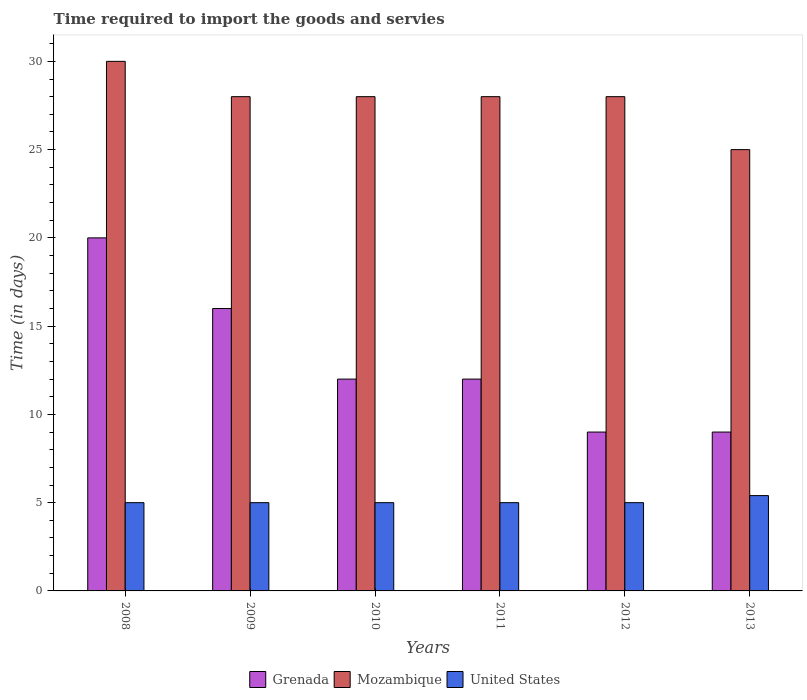How many different coloured bars are there?
Your answer should be very brief. 3. Are the number of bars per tick equal to the number of legend labels?
Give a very brief answer. Yes. How many bars are there on the 4th tick from the left?
Offer a terse response. 3. In how many cases, is the number of bars for a given year not equal to the number of legend labels?
Your answer should be very brief. 0. What is the number of days required to import the goods and services in Grenada in 2013?
Give a very brief answer. 9. Across all years, what is the maximum number of days required to import the goods and services in Mozambique?
Make the answer very short. 30. In which year was the number of days required to import the goods and services in United States maximum?
Your response must be concise. 2013. In which year was the number of days required to import the goods and services in United States minimum?
Ensure brevity in your answer.  2008. What is the total number of days required to import the goods and services in Grenada in the graph?
Provide a succinct answer. 78. What is the difference between the number of days required to import the goods and services in Mozambique in 2008 and the number of days required to import the goods and services in Grenada in 2013?
Offer a very short reply. 21. What is the average number of days required to import the goods and services in United States per year?
Give a very brief answer. 5.07. In the year 2013, what is the difference between the number of days required to import the goods and services in United States and number of days required to import the goods and services in Mozambique?
Give a very brief answer. -19.6. What is the ratio of the number of days required to import the goods and services in Mozambique in 2008 to that in 2011?
Offer a very short reply. 1.07. Is the number of days required to import the goods and services in Mozambique in 2009 less than that in 2012?
Keep it short and to the point. No. Is the difference between the number of days required to import the goods and services in United States in 2010 and 2013 greater than the difference between the number of days required to import the goods and services in Mozambique in 2010 and 2013?
Ensure brevity in your answer.  No. What is the difference between the highest and the lowest number of days required to import the goods and services in United States?
Your answer should be very brief. 0.4. What does the 2nd bar from the left in 2011 represents?
Your answer should be very brief. Mozambique. Is it the case that in every year, the sum of the number of days required to import the goods and services in United States and number of days required to import the goods and services in Grenada is greater than the number of days required to import the goods and services in Mozambique?
Give a very brief answer. No. Are all the bars in the graph horizontal?
Provide a succinct answer. No. How many years are there in the graph?
Ensure brevity in your answer.  6. How many legend labels are there?
Provide a short and direct response. 3. What is the title of the graph?
Make the answer very short. Time required to import the goods and servies. What is the label or title of the Y-axis?
Your answer should be very brief. Time (in days). What is the Time (in days) of Grenada in 2008?
Keep it short and to the point. 20. What is the Time (in days) in United States in 2008?
Make the answer very short. 5. What is the Time (in days) of Grenada in 2009?
Offer a terse response. 16. What is the Time (in days) in Grenada in 2010?
Offer a very short reply. 12. What is the Time (in days) of Grenada in 2011?
Give a very brief answer. 12. What is the Time (in days) of United States in 2011?
Your answer should be compact. 5. What is the Time (in days) in Mozambique in 2012?
Keep it short and to the point. 28. What is the Time (in days) in United States in 2012?
Give a very brief answer. 5. What is the Time (in days) in Mozambique in 2013?
Offer a terse response. 25. Across all years, what is the maximum Time (in days) in Grenada?
Your answer should be compact. 20. Across all years, what is the maximum Time (in days) of United States?
Keep it short and to the point. 5.4. What is the total Time (in days) of Grenada in the graph?
Offer a terse response. 78. What is the total Time (in days) of Mozambique in the graph?
Your response must be concise. 167. What is the total Time (in days) of United States in the graph?
Keep it short and to the point. 30.4. What is the difference between the Time (in days) in Grenada in 2008 and that in 2009?
Offer a very short reply. 4. What is the difference between the Time (in days) of Mozambique in 2008 and that in 2010?
Provide a short and direct response. 2. What is the difference between the Time (in days) of United States in 2008 and that in 2010?
Offer a very short reply. 0. What is the difference between the Time (in days) in Grenada in 2008 and that in 2012?
Offer a very short reply. 11. What is the difference between the Time (in days) in Grenada in 2008 and that in 2013?
Your response must be concise. 11. What is the difference between the Time (in days) of Mozambique in 2008 and that in 2013?
Your response must be concise. 5. What is the difference between the Time (in days) in Grenada in 2009 and that in 2010?
Offer a very short reply. 4. What is the difference between the Time (in days) of Mozambique in 2009 and that in 2010?
Keep it short and to the point. 0. What is the difference between the Time (in days) of United States in 2009 and that in 2010?
Provide a short and direct response. 0. What is the difference between the Time (in days) in Mozambique in 2009 and that in 2011?
Your answer should be compact. 0. What is the difference between the Time (in days) of United States in 2009 and that in 2011?
Offer a terse response. 0. What is the difference between the Time (in days) in Mozambique in 2009 and that in 2012?
Provide a succinct answer. 0. What is the difference between the Time (in days) of Grenada in 2009 and that in 2013?
Make the answer very short. 7. What is the difference between the Time (in days) in Grenada in 2010 and that in 2011?
Give a very brief answer. 0. What is the difference between the Time (in days) of Grenada in 2010 and that in 2012?
Keep it short and to the point. 3. What is the difference between the Time (in days) in Mozambique in 2010 and that in 2012?
Keep it short and to the point. 0. What is the difference between the Time (in days) in United States in 2010 and that in 2012?
Offer a terse response. 0. What is the difference between the Time (in days) of United States in 2010 and that in 2013?
Give a very brief answer. -0.4. What is the difference between the Time (in days) in Grenada in 2011 and that in 2012?
Offer a very short reply. 3. What is the difference between the Time (in days) in United States in 2011 and that in 2012?
Make the answer very short. 0. What is the difference between the Time (in days) in United States in 2011 and that in 2013?
Your answer should be compact. -0.4. What is the difference between the Time (in days) of Grenada in 2008 and the Time (in days) of Mozambique in 2009?
Provide a succinct answer. -8. What is the difference between the Time (in days) of Mozambique in 2008 and the Time (in days) of United States in 2009?
Offer a terse response. 25. What is the difference between the Time (in days) in Grenada in 2008 and the Time (in days) in United States in 2010?
Your answer should be compact. 15. What is the difference between the Time (in days) in Grenada in 2008 and the Time (in days) in Mozambique in 2011?
Offer a terse response. -8. What is the difference between the Time (in days) in Grenada in 2008 and the Time (in days) in United States in 2011?
Offer a very short reply. 15. What is the difference between the Time (in days) of Mozambique in 2008 and the Time (in days) of United States in 2011?
Ensure brevity in your answer.  25. What is the difference between the Time (in days) of Grenada in 2008 and the Time (in days) of Mozambique in 2012?
Ensure brevity in your answer.  -8. What is the difference between the Time (in days) of Grenada in 2008 and the Time (in days) of United States in 2012?
Your response must be concise. 15. What is the difference between the Time (in days) of Grenada in 2008 and the Time (in days) of Mozambique in 2013?
Keep it short and to the point. -5. What is the difference between the Time (in days) of Mozambique in 2008 and the Time (in days) of United States in 2013?
Provide a succinct answer. 24.6. What is the difference between the Time (in days) of Grenada in 2009 and the Time (in days) of United States in 2010?
Make the answer very short. 11. What is the difference between the Time (in days) of Mozambique in 2009 and the Time (in days) of United States in 2010?
Your response must be concise. 23. What is the difference between the Time (in days) in Grenada in 2009 and the Time (in days) in Mozambique in 2011?
Provide a short and direct response. -12. What is the difference between the Time (in days) of Grenada in 2009 and the Time (in days) of United States in 2011?
Your answer should be very brief. 11. What is the difference between the Time (in days) in Grenada in 2009 and the Time (in days) in United States in 2012?
Keep it short and to the point. 11. What is the difference between the Time (in days) in Grenada in 2009 and the Time (in days) in Mozambique in 2013?
Your answer should be very brief. -9. What is the difference between the Time (in days) in Grenada in 2009 and the Time (in days) in United States in 2013?
Offer a very short reply. 10.6. What is the difference between the Time (in days) of Mozambique in 2009 and the Time (in days) of United States in 2013?
Provide a succinct answer. 22.6. What is the difference between the Time (in days) in Grenada in 2010 and the Time (in days) in United States in 2011?
Offer a terse response. 7. What is the difference between the Time (in days) of Mozambique in 2010 and the Time (in days) of United States in 2011?
Provide a succinct answer. 23. What is the difference between the Time (in days) of Grenada in 2010 and the Time (in days) of United States in 2012?
Ensure brevity in your answer.  7. What is the difference between the Time (in days) in Mozambique in 2010 and the Time (in days) in United States in 2012?
Provide a succinct answer. 23. What is the difference between the Time (in days) of Grenada in 2010 and the Time (in days) of Mozambique in 2013?
Your answer should be very brief. -13. What is the difference between the Time (in days) in Mozambique in 2010 and the Time (in days) in United States in 2013?
Offer a terse response. 22.6. What is the difference between the Time (in days) in Mozambique in 2011 and the Time (in days) in United States in 2012?
Ensure brevity in your answer.  23. What is the difference between the Time (in days) in Grenada in 2011 and the Time (in days) in United States in 2013?
Your answer should be very brief. 6.6. What is the difference between the Time (in days) in Mozambique in 2011 and the Time (in days) in United States in 2013?
Provide a short and direct response. 22.6. What is the difference between the Time (in days) of Mozambique in 2012 and the Time (in days) of United States in 2013?
Give a very brief answer. 22.6. What is the average Time (in days) in Mozambique per year?
Ensure brevity in your answer.  27.83. What is the average Time (in days) in United States per year?
Your answer should be compact. 5.07. In the year 2008, what is the difference between the Time (in days) of Grenada and Time (in days) of United States?
Offer a very short reply. 15. In the year 2008, what is the difference between the Time (in days) of Mozambique and Time (in days) of United States?
Make the answer very short. 25. In the year 2009, what is the difference between the Time (in days) in Mozambique and Time (in days) in United States?
Ensure brevity in your answer.  23. In the year 2010, what is the difference between the Time (in days) of Grenada and Time (in days) of Mozambique?
Keep it short and to the point. -16. In the year 2010, what is the difference between the Time (in days) in Grenada and Time (in days) in United States?
Keep it short and to the point. 7. In the year 2012, what is the difference between the Time (in days) of Grenada and Time (in days) of Mozambique?
Your response must be concise. -19. In the year 2012, what is the difference between the Time (in days) of Mozambique and Time (in days) of United States?
Your answer should be very brief. 23. In the year 2013, what is the difference between the Time (in days) in Grenada and Time (in days) in United States?
Make the answer very short. 3.6. In the year 2013, what is the difference between the Time (in days) in Mozambique and Time (in days) in United States?
Offer a terse response. 19.6. What is the ratio of the Time (in days) in Grenada in 2008 to that in 2009?
Give a very brief answer. 1.25. What is the ratio of the Time (in days) in Mozambique in 2008 to that in 2009?
Provide a short and direct response. 1.07. What is the ratio of the Time (in days) of Grenada in 2008 to that in 2010?
Offer a terse response. 1.67. What is the ratio of the Time (in days) of Mozambique in 2008 to that in 2010?
Ensure brevity in your answer.  1.07. What is the ratio of the Time (in days) in United States in 2008 to that in 2010?
Provide a short and direct response. 1. What is the ratio of the Time (in days) in Grenada in 2008 to that in 2011?
Offer a very short reply. 1.67. What is the ratio of the Time (in days) in Mozambique in 2008 to that in 2011?
Offer a terse response. 1.07. What is the ratio of the Time (in days) in United States in 2008 to that in 2011?
Make the answer very short. 1. What is the ratio of the Time (in days) of Grenada in 2008 to that in 2012?
Your answer should be compact. 2.22. What is the ratio of the Time (in days) in Mozambique in 2008 to that in 2012?
Ensure brevity in your answer.  1.07. What is the ratio of the Time (in days) in Grenada in 2008 to that in 2013?
Provide a short and direct response. 2.22. What is the ratio of the Time (in days) in Mozambique in 2008 to that in 2013?
Make the answer very short. 1.2. What is the ratio of the Time (in days) in United States in 2008 to that in 2013?
Provide a succinct answer. 0.93. What is the ratio of the Time (in days) in Grenada in 2009 to that in 2010?
Provide a succinct answer. 1.33. What is the ratio of the Time (in days) of Mozambique in 2009 to that in 2010?
Provide a short and direct response. 1. What is the ratio of the Time (in days) of Mozambique in 2009 to that in 2011?
Your answer should be very brief. 1. What is the ratio of the Time (in days) in United States in 2009 to that in 2011?
Ensure brevity in your answer.  1. What is the ratio of the Time (in days) of Grenada in 2009 to that in 2012?
Your answer should be compact. 1.78. What is the ratio of the Time (in days) in Mozambique in 2009 to that in 2012?
Offer a very short reply. 1. What is the ratio of the Time (in days) in United States in 2009 to that in 2012?
Give a very brief answer. 1. What is the ratio of the Time (in days) in Grenada in 2009 to that in 2013?
Offer a very short reply. 1.78. What is the ratio of the Time (in days) in Mozambique in 2009 to that in 2013?
Give a very brief answer. 1.12. What is the ratio of the Time (in days) in United States in 2009 to that in 2013?
Give a very brief answer. 0.93. What is the ratio of the Time (in days) in Grenada in 2010 to that in 2011?
Your answer should be compact. 1. What is the ratio of the Time (in days) of Mozambique in 2010 to that in 2011?
Your answer should be very brief. 1. What is the ratio of the Time (in days) in United States in 2010 to that in 2011?
Offer a terse response. 1. What is the ratio of the Time (in days) of Mozambique in 2010 to that in 2012?
Make the answer very short. 1. What is the ratio of the Time (in days) in Mozambique in 2010 to that in 2013?
Offer a terse response. 1.12. What is the ratio of the Time (in days) in United States in 2010 to that in 2013?
Offer a very short reply. 0.93. What is the ratio of the Time (in days) of Grenada in 2011 to that in 2012?
Give a very brief answer. 1.33. What is the ratio of the Time (in days) of United States in 2011 to that in 2012?
Offer a terse response. 1. What is the ratio of the Time (in days) of Mozambique in 2011 to that in 2013?
Your answer should be very brief. 1.12. What is the ratio of the Time (in days) in United States in 2011 to that in 2013?
Make the answer very short. 0.93. What is the ratio of the Time (in days) in Mozambique in 2012 to that in 2013?
Give a very brief answer. 1.12. What is the ratio of the Time (in days) in United States in 2012 to that in 2013?
Offer a very short reply. 0.93. What is the difference between the highest and the second highest Time (in days) of Grenada?
Ensure brevity in your answer.  4. What is the difference between the highest and the lowest Time (in days) in Mozambique?
Your answer should be compact. 5. 